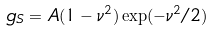Convert formula to latex. <formula><loc_0><loc_0><loc_500><loc_500>g _ { S } = A ( 1 - \nu ^ { 2 } ) \exp ( - \nu ^ { 2 } / 2 )</formula> 